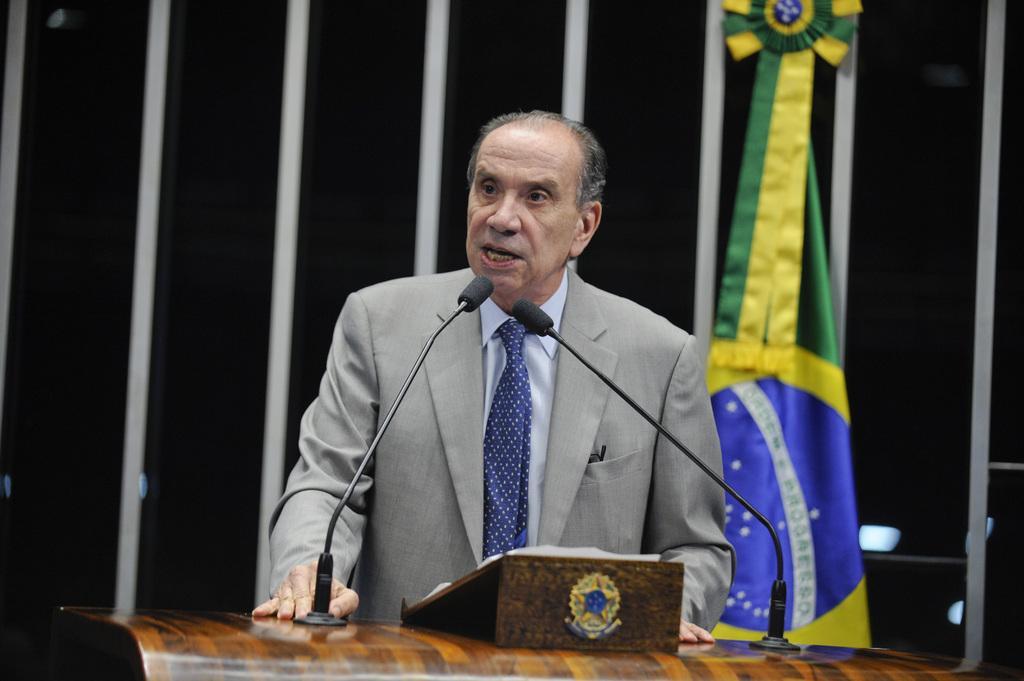Can you describe this image briefly? In this image in the front there is a podium and on the top of the podium there are mics. In the center there is a man standing and speaking. In the background there is a flag and there is a curtain which is black and white in colour. 